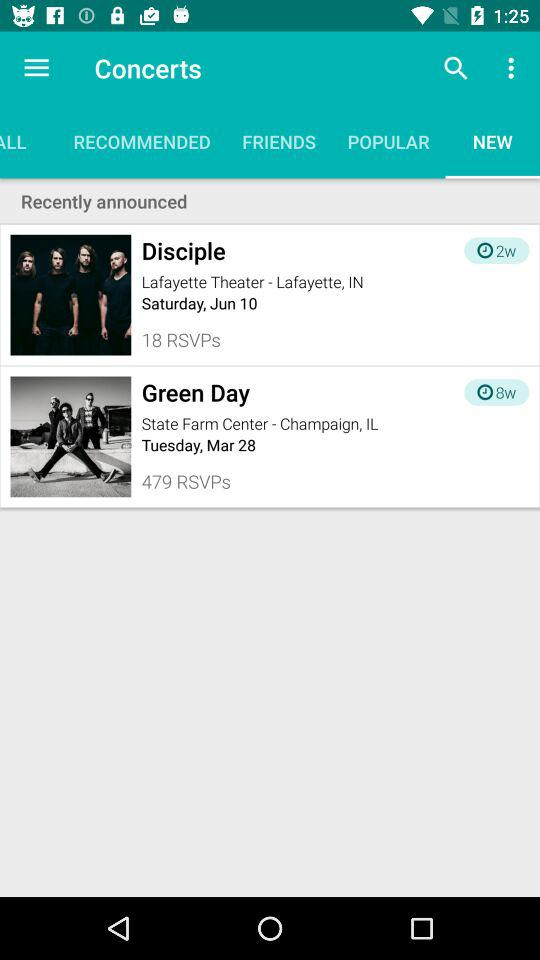What is the date of the concert "Disciple"? The date of the concert "Disciple" is Saturday, June 10. 